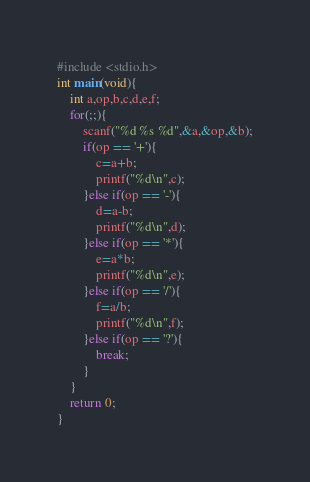<code> <loc_0><loc_0><loc_500><loc_500><_C_>#include <stdio.h>
int main(void){
	int a,op,b,c,d,e,f;
	for(;;){
		scanf("%d %s %d",&a,&op,&b);
		if(op == '+'){
			c=a+b;
			printf("%d\n",c);
		}else if(op == '-'){
			d=a-b;
			printf("%d\n",d);
		}else if(op == '*'){
			e=a*b;
			printf("%d\n",e);
		}else if(op == '/'){
			f=a/b;
			printf("%d\n",f);
		}else if(op == '?'){
			break;
		}
	}
	return 0;
}</code> 